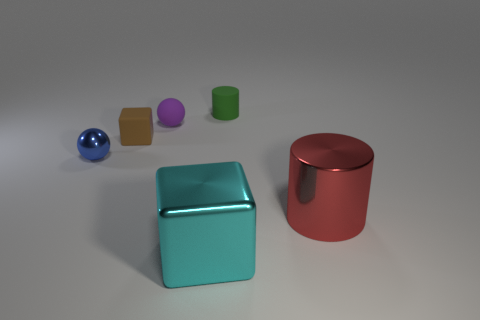What number of small rubber cylinders are there?
Give a very brief answer. 1. Is the material of the brown block the same as the sphere that is in front of the matte block?
Ensure brevity in your answer.  No. What size is the rubber cylinder?
Give a very brief answer. Small. There is a small purple object; does it have the same shape as the shiny object that is left of the purple matte sphere?
Make the answer very short. Yes. What color is the small cube that is made of the same material as the tiny purple sphere?
Your response must be concise. Brown. There is a matte thing that is in front of the purple thing; what size is it?
Keep it short and to the point. Small. Is the number of big cylinders to the right of the large red metal cylinder less than the number of big red metallic objects?
Provide a succinct answer. Yes. Are there fewer red cylinders than small purple metal cubes?
Offer a very short reply. No. There is a cylinder that is in front of the small rubber object that is behind the purple matte object; what color is it?
Keep it short and to the point. Red. There is a block that is in front of the blue object that is left of the shiny thing that is right of the metal cube; what is its material?
Keep it short and to the point. Metal. 